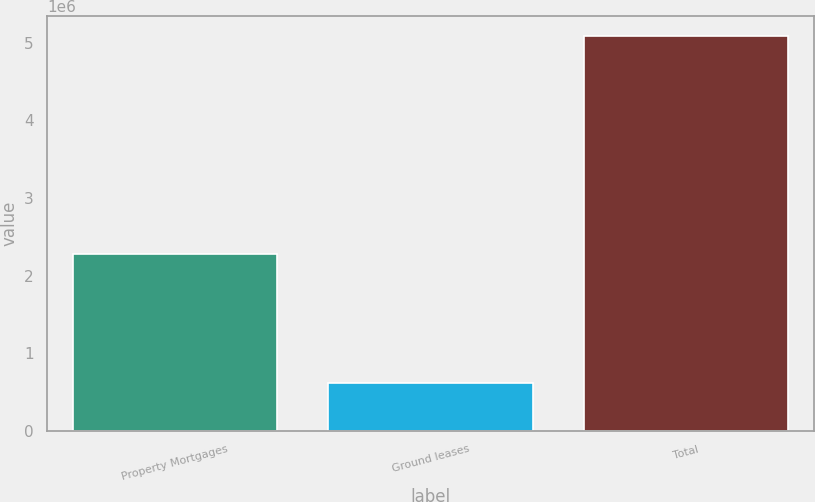Convert chart. <chart><loc_0><loc_0><loc_500><loc_500><bar_chart><fcel>Property Mortgages<fcel>Ground leases<fcel>Total<nl><fcel>2.27819e+06<fcel>615450<fcel>5.08365e+06<nl></chart> 